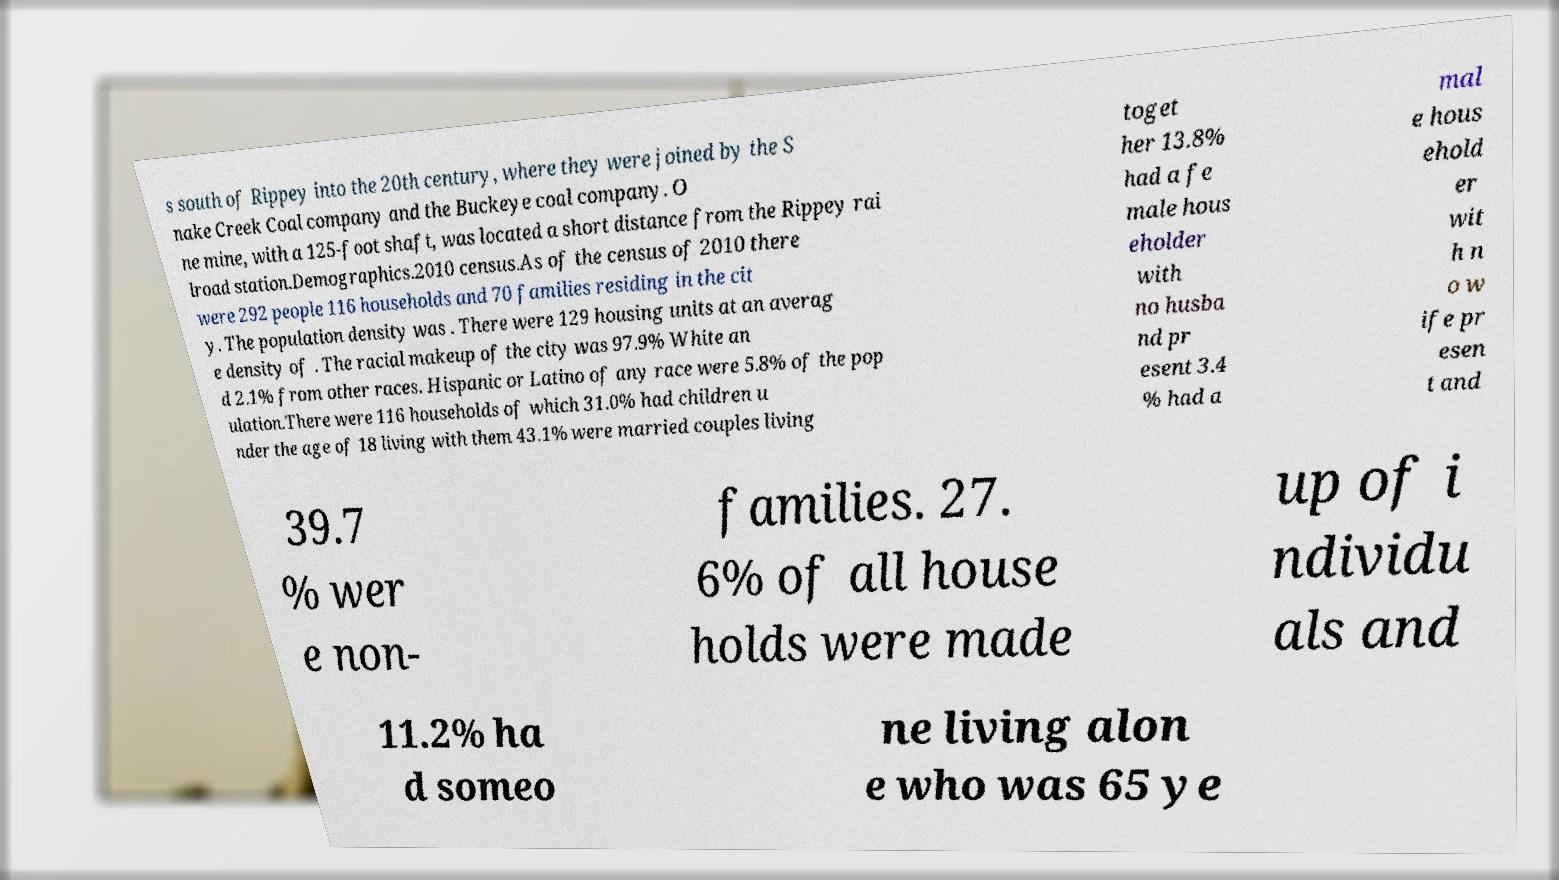For documentation purposes, I need the text within this image transcribed. Could you provide that? s south of Rippey into the 20th century, where they were joined by the S nake Creek Coal company and the Buckeye coal company. O ne mine, with a 125-foot shaft, was located a short distance from the Rippey rai lroad station.Demographics.2010 census.As of the census of 2010 there were 292 people 116 households and 70 families residing in the cit y. The population density was . There were 129 housing units at an averag e density of . The racial makeup of the city was 97.9% White an d 2.1% from other races. Hispanic or Latino of any race were 5.8% of the pop ulation.There were 116 households of which 31.0% had children u nder the age of 18 living with them 43.1% were married couples living toget her 13.8% had a fe male hous eholder with no husba nd pr esent 3.4 % had a mal e hous ehold er wit h n o w ife pr esen t and 39.7 % wer e non- families. 27. 6% of all house holds were made up of i ndividu als and 11.2% ha d someo ne living alon e who was 65 ye 